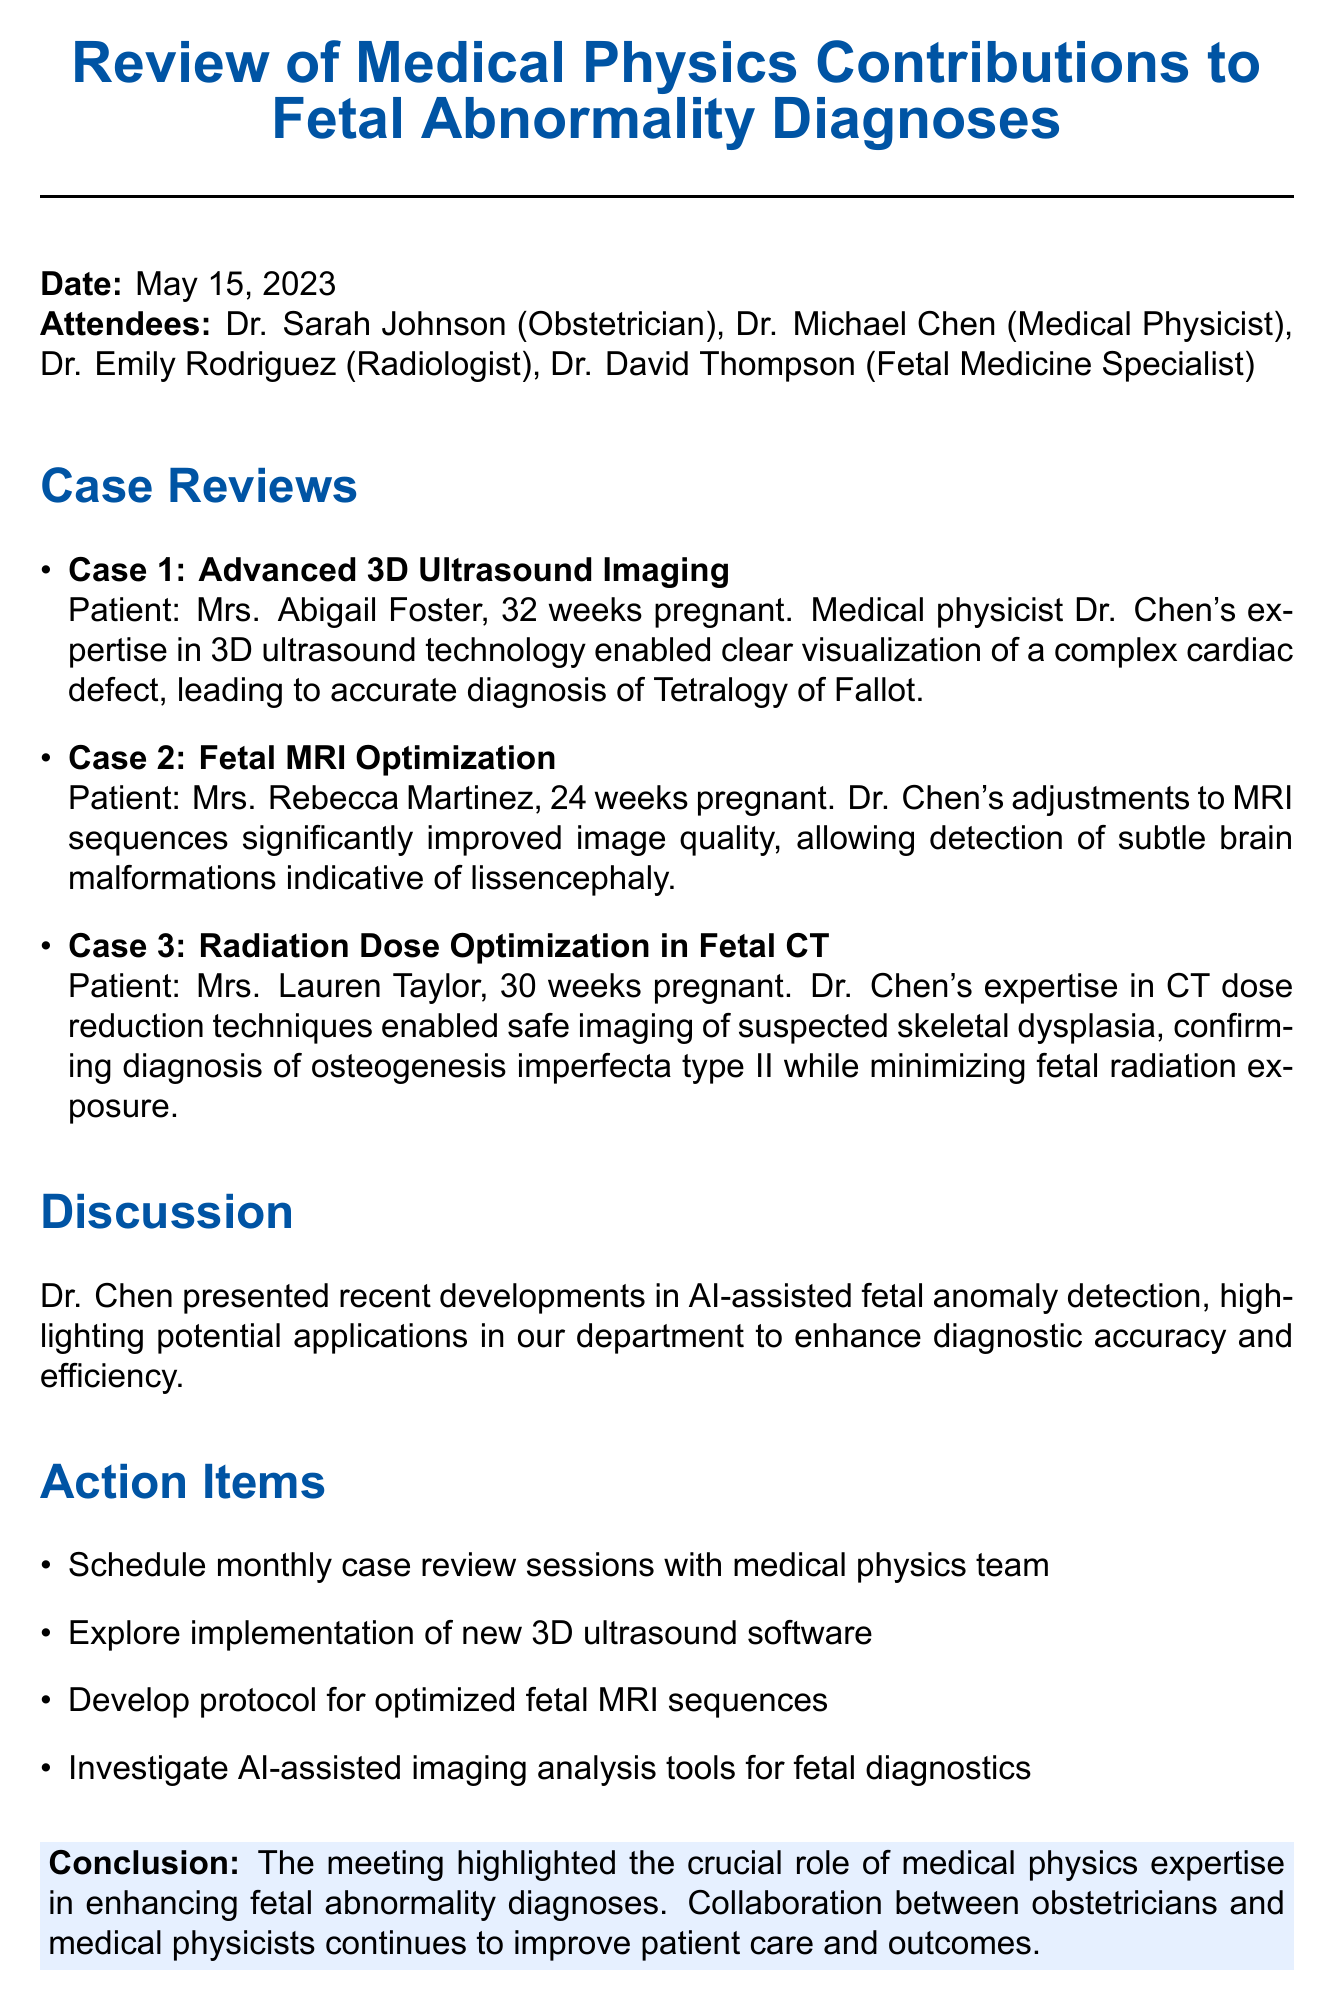What is the meeting date? The meeting date is specified in the document as May 15, 2023.
Answer: May 15, 2023 Who presented the advances in AI-assisted fetal anomaly detection? The document names Dr. Chen as the one who presented recent developments in AI-assisted fetal anomaly detection.
Answer: Dr. Chen What was the diagnosis for Mrs. Abigail Foster? The document details that the diagnosis for Mrs. Abigail Foster was Tetralogy of Fallot.
Answer: Tetralogy of Fallot How many action items were listed in the document? The document lists four action items under the Action Items section.
Answer: Four What imaging technique was optimized for Mrs. Rebecca Martinez? The document states that an MRI was optimized for Mrs. Rebecca Martinez.
Answer: MRI What fetal abnormality was diagnosed in Mrs. Lauren Taylor? Mrs. Lauren Taylor was diagnosed with osteogenesis imperfecta type II as per the document.
Answer: Osteogenesis imperfecta type II What technology helped visualize the cardiac defect in Case 1? The document attributes the clear visualization of the cardiac defect to advanced 3D ultrasound technology.
Answer: Advanced 3D ultrasound technology What type of meeting minutes is this document classified as? The content of the document is classified as meeting minutes focused on reviewing case contributions.
Answer: Meeting minutes 